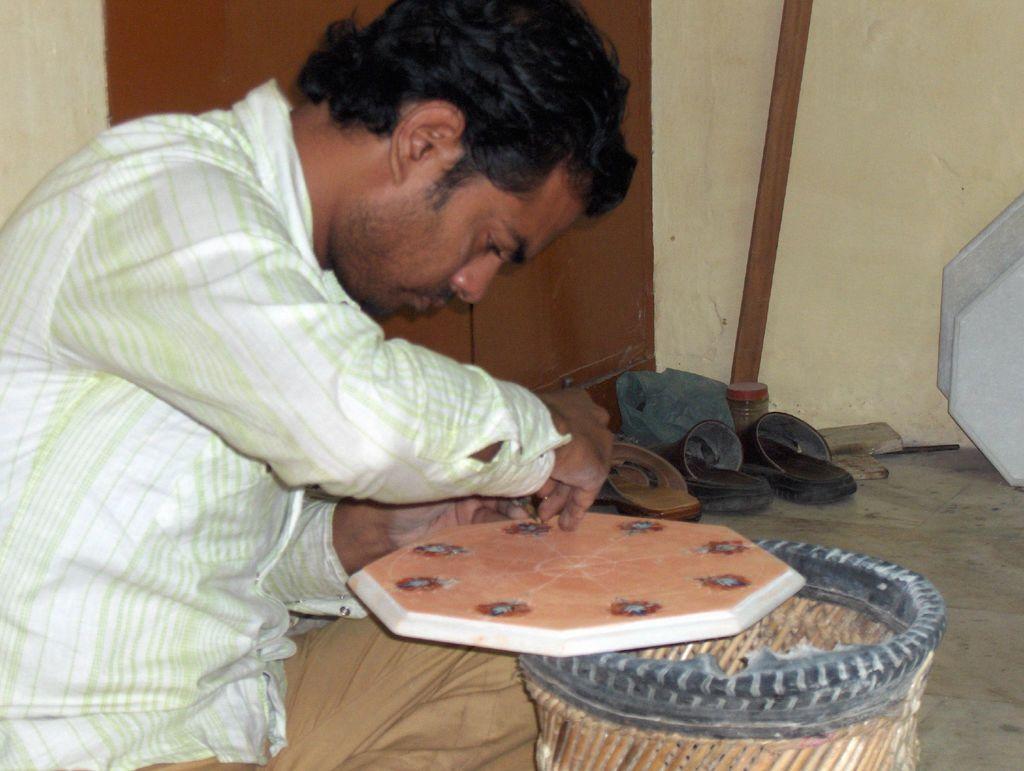Can you describe this image briefly? In this image a person is sitting and working on an object, behind there are few foot-wears and a wooden stick. 